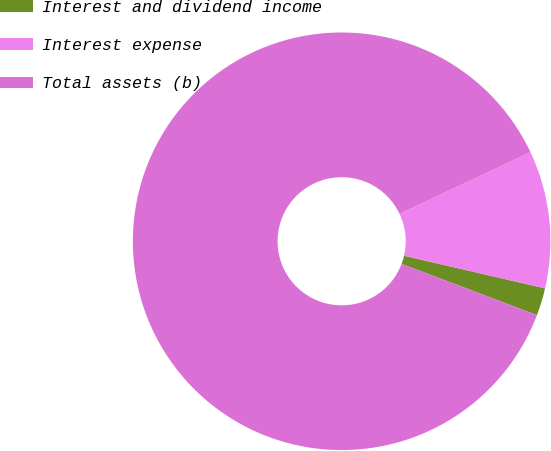<chart> <loc_0><loc_0><loc_500><loc_500><pie_chart><fcel>Interest and dividend income<fcel>Interest expense<fcel>Total assets (b)<nl><fcel>2.13%<fcel>10.64%<fcel>87.23%<nl></chart> 